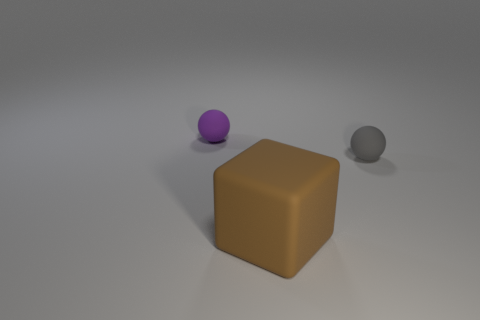Add 2 small red metallic spheres. How many objects exist? 5 Subtract all blocks. How many objects are left? 2 Add 1 tiny things. How many tiny things exist? 3 Subtract 0 blue spheres. How many objects are left? 3 Subtract all tiny red shiny cylinders. Subtract all purple rubber objects. How many objects are left? 2 Add 1 large rubber blocks. How many large rubber blocks are left? 2 